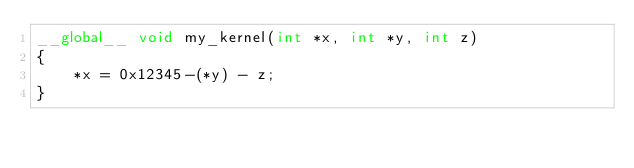Convert code to text. <code><loc_0><loc_0><loc_500><loc_500><_Cuda_>__global__ void my_kernel(int *x, int *y, int z)
{
	*x = 0x12345-(*y) - z;
}
</code> 